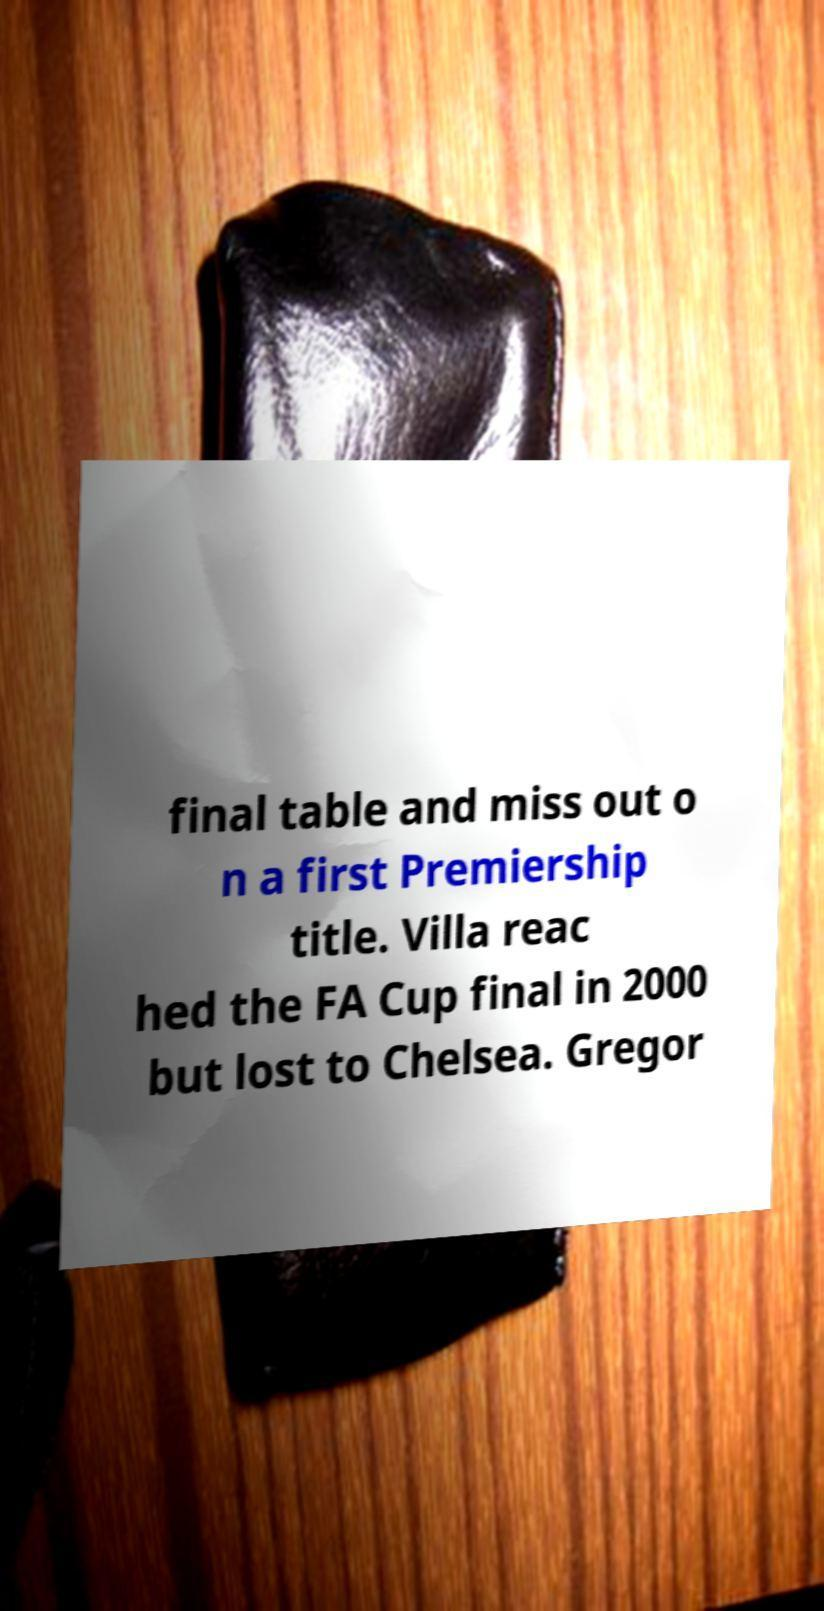Could you extract and type out the text from this image? final table and miss out o n a first Premiership title. Villa reac hed the FA Cup final in 2000 but lost to Chelsea. Gregor 